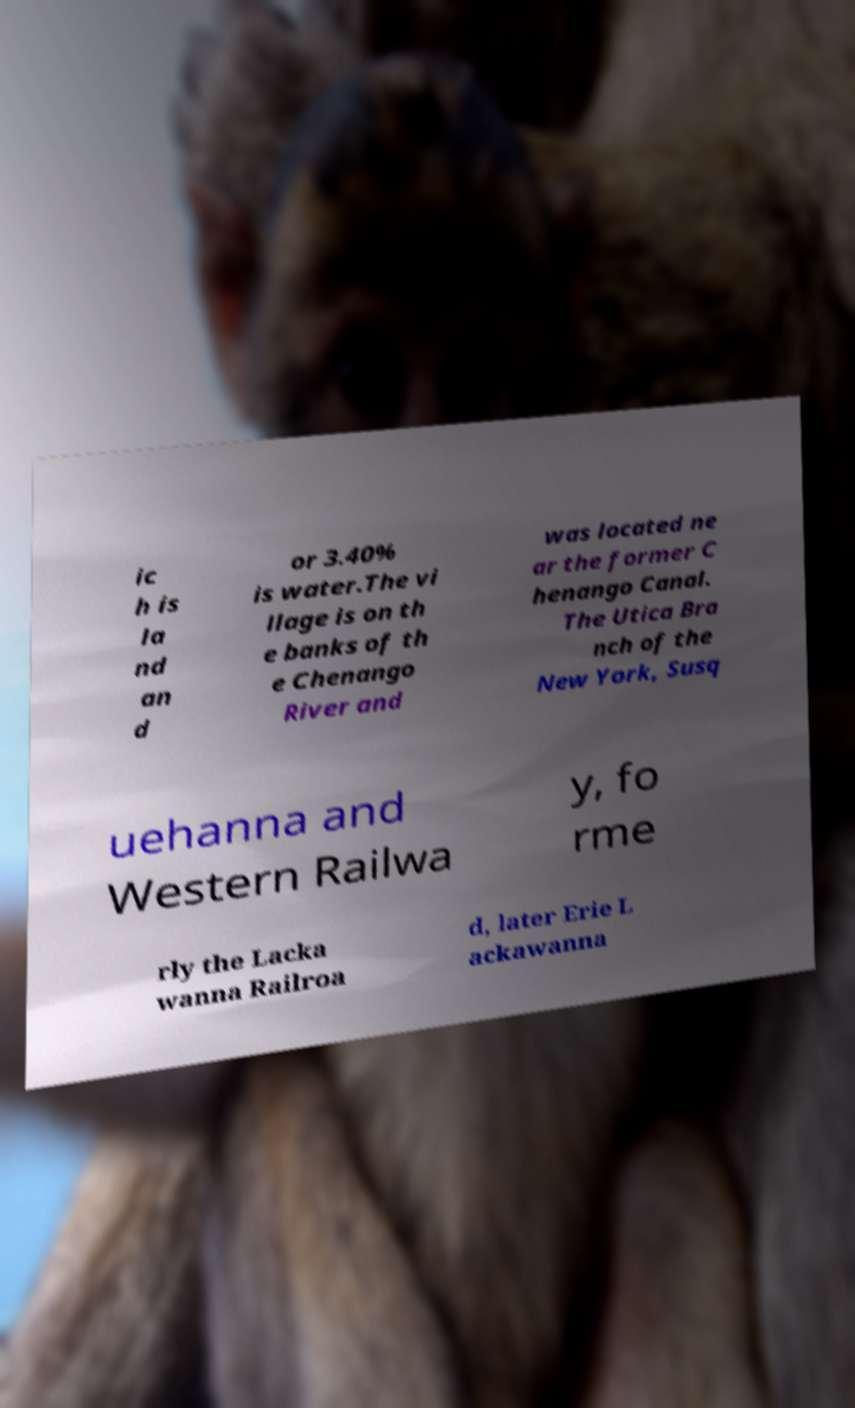Please identify and transcribe the text found in this image. ic h is la nd an d or 3.40% is water.The vi llage is on th e banks of th e Chenango River and was located ne ar the former C henango Canal. The Utica Bra nch of the New York, Susq uehanna and Western Railwa y, fo rme rly the Lacka wanna Railroa d, later Erie L ackawanna 